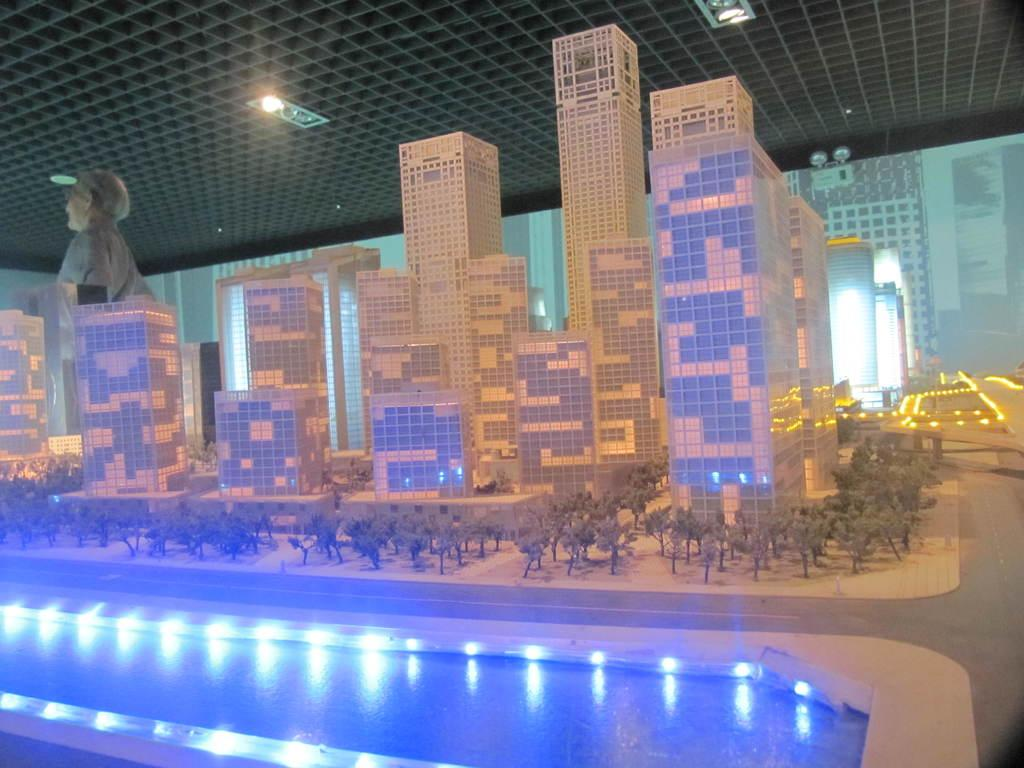What is one of the main elements in the image? There is water in the image. What type of structures can be seen in the image? There are buildings in the image. What other natural elements are present in the image? There are trees in the image. Can you describe the statue in the image? There is a statue of a person in the image. What type of illumination is present in the image? There are lights in the image. What architectural feature can be seen in the background of the image? There is a roof visible in the background of the image. What type of duck can be seen shaking off water in the image? There is no duck present in the image, and therefore no such activity can be observed. 